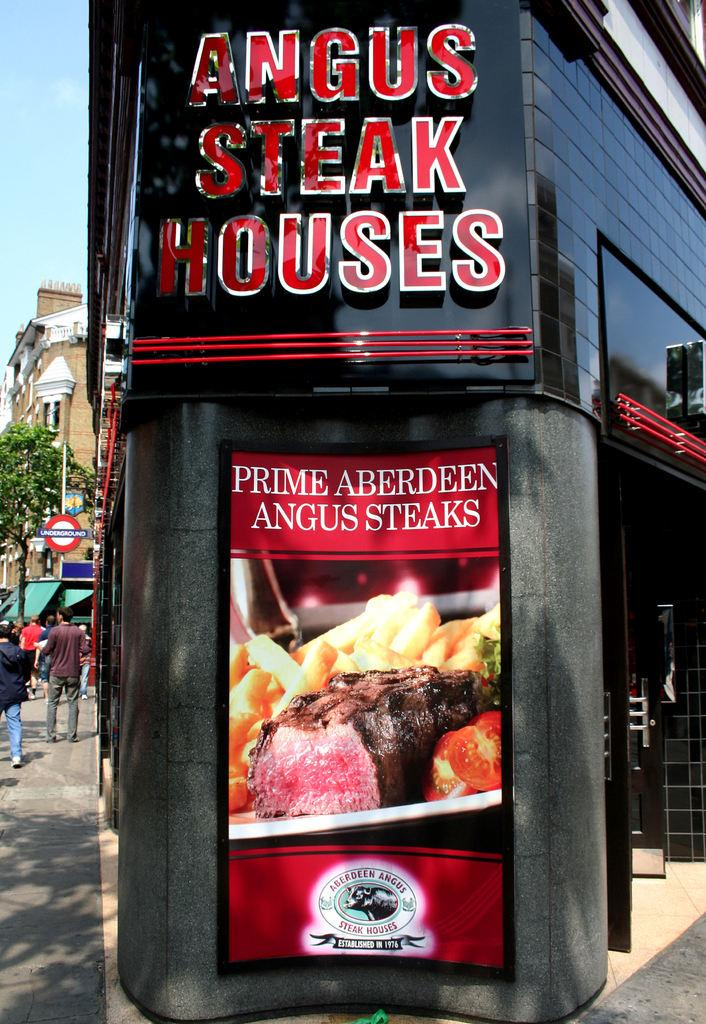<image>
Present a compact description of the photo's key features. An advertisement for Angus Steak Houses Prime Aberdeen Angus Steaks. 